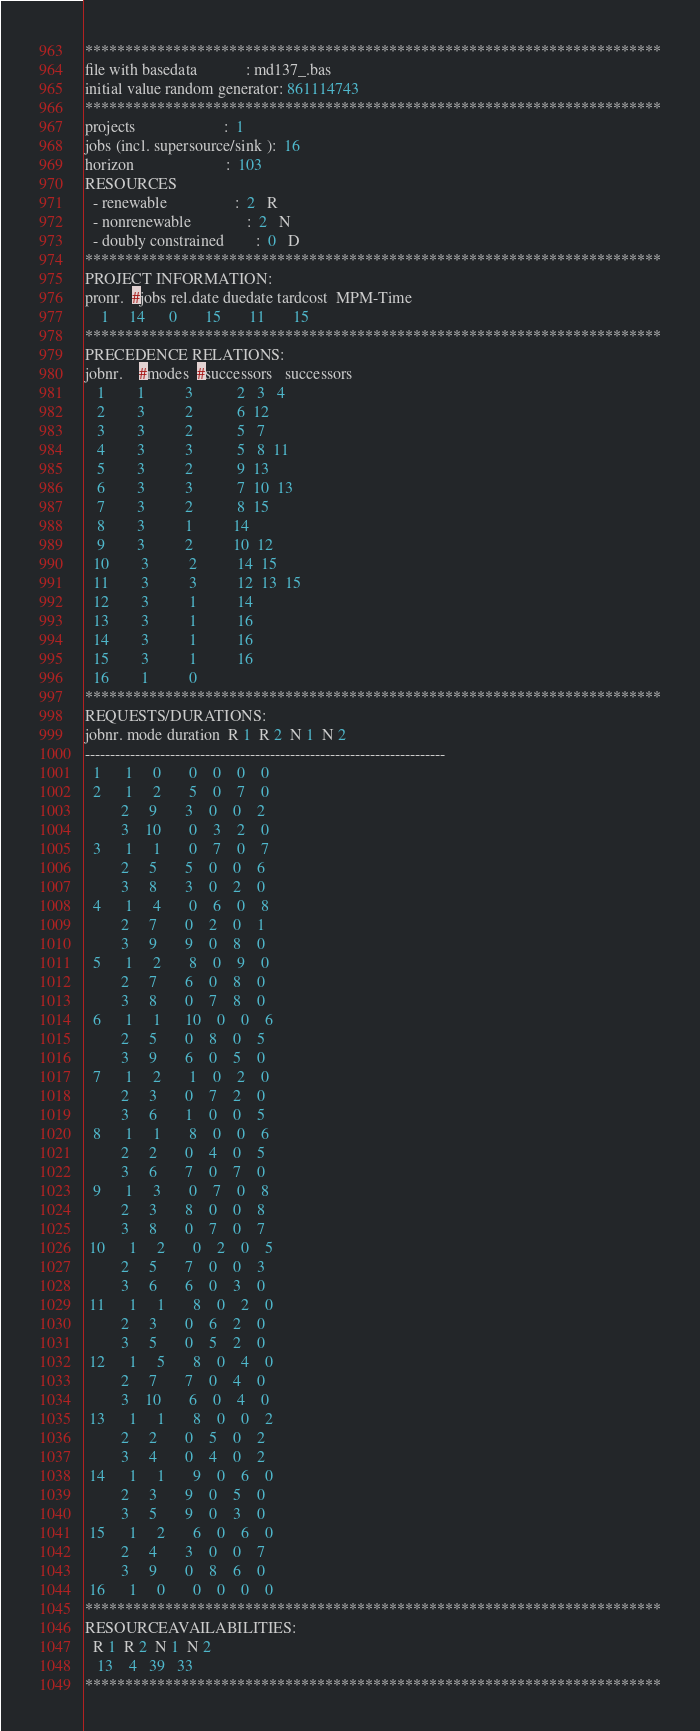<code> <loc_0><loc_0><loc_500><loc_500><_ObjectiveC_>************************************************************************
file with basedata            : md137_.bas
initial value random generator: 861114743
************************************************************************
projects                      :  1
jobs (incl. supersource/sink ):  16
horizon                       :  103
RESOURCES
  - renewable                 :  2   R
  - nonrenewable              :  2   N
  - doubly constrained        :  0   D
************************************************************************
PROJECT INFORMATION:
pronr.  #jobs rel.date duedate tardcost  MPM-Time
    1     14      0       15       11       15
************************************************************************
PRECEDENCE RELATIONS:
jobnr.    #modes  #successors   successors
   1        1          3           2   3   4
   2        3          2           6  12
   3        3          2           5   7
   4        3          3           5   8  11
   5        3          2           9  13
   6        3          3           7  10  13
   7        3          2           8  15
   8        3          1          14
   9        3          2          10  12
  10        3          2          14  15
  11        3          3          12  13  15
  12        3          1          14
  13        3          1          16
  14        3          1          16
  15        3          1          16
  16        1          0        
************************************************************************
REQUESTS/DURATIONS:
jobnr. mode duration  R 1  R 2  N 1  N 2
------------------------------------------------------------------------
  1      1     0       0    0    0    0
  2      1     2       5    0    7    0
         2     9       3    0    0    2
         3    10       0    3    2    0
  3      1     1       0    7    0    7
         2     5       5    0    0    6
         3     8       3    0    2    0
  4      1     4       0    6    0    8
         2     7       0    2    0    1
         3     9       9    0    8    0
  5      1     2       8    0    9    0
         2     7       6    0    8    0
         3     8       0    7    8    0
  6      1     1      10    0    0    6
         2     5       0    8    0    5
         3     9       6    0    5    0
  7      1     2       1    0    2    0
         2     3       0    7    2    0
         3     6       1    0    0    5
  8      1     1       8    0    0    6
         2     2       0    4    0    5
         3     6       7    0    7    0
  9      1     3       0    7    0    8
         2     3       8    0    0    8
         3     8       0    7    0    7
 10      1     2       0    2    0    5
         2     5       7    0    0    3
         3     6       6    0    3    0
 11      1     1       8    0    2    0
         2     3       0    6    2    0
         3     5       0    5    2    0
 12      1     5       8    0    4    0
         2     7       7    0    4    0
         3    10       6    0    4    0
 13      1     1       8    0    0    2
         2     2       0    5    0    2
         3     4       0    4    0    2
 14      1     1       9    0    6    0
         2     3       9    0    5    0
         3     5       9    0    3    0
 15      1     2       6    0    6    0
         2     4       3    0    0    7
         3     9       0    8    6    0
 16      1     0       0    0    0    0
************************************************************************
RESOURCEAVAILABILITIES:
  R 1  R 2  N 1  N 2
   13    4   39   33
************************************************************************
</code> 